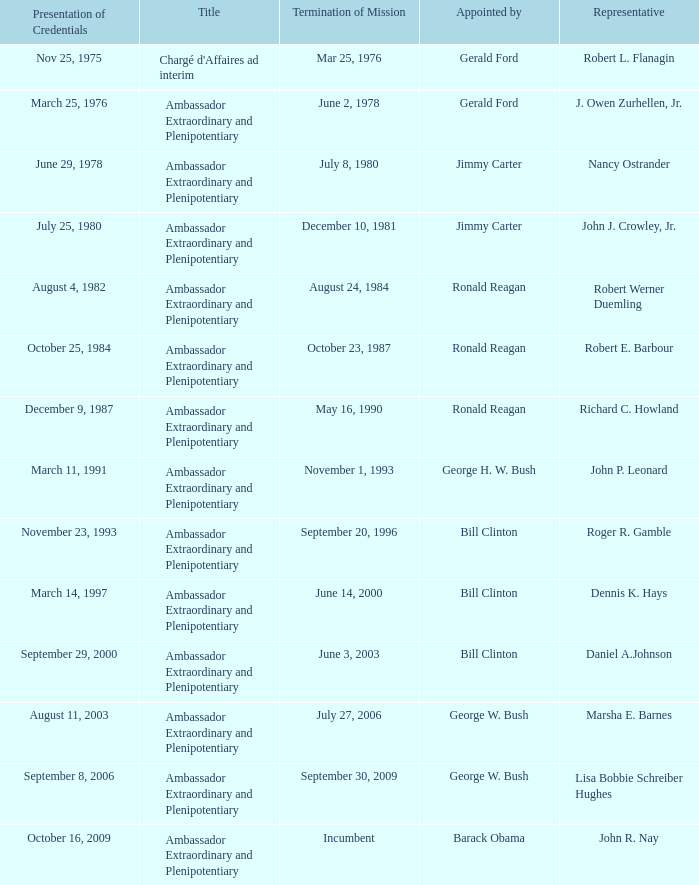What was the Termination of Mission date for the ambassador who was appointed by Barack Obama? Incumbent. 